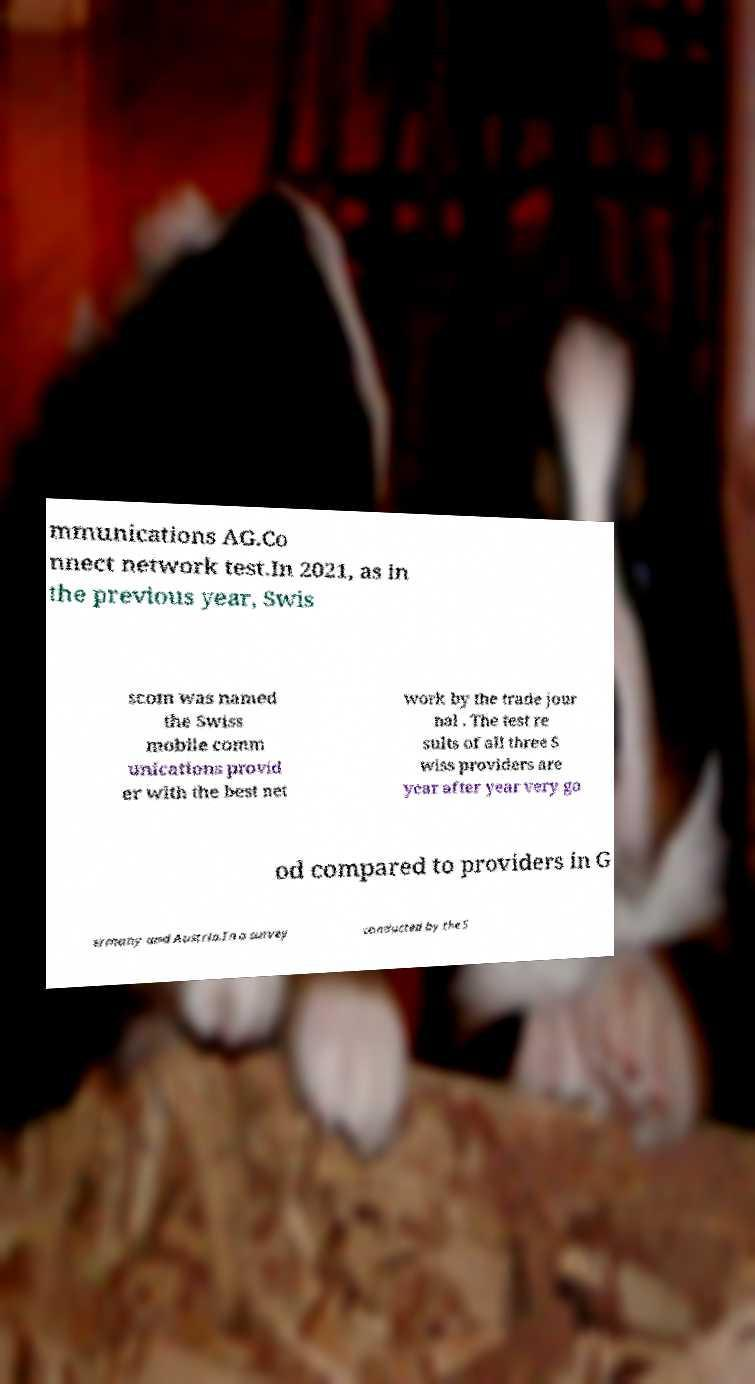Please read and relay the text visible in this image. What does it say? mmunications AG.Co nnect network test.In 2021, as in the previous year, Swis scom was named the Swiss mobile comm unications provid er with the best net work by the trade jour nal . The test re sults of all three S wiss providers are year after year very go od compared to providers in G ermany and Austria.In a survey conducted by the S 